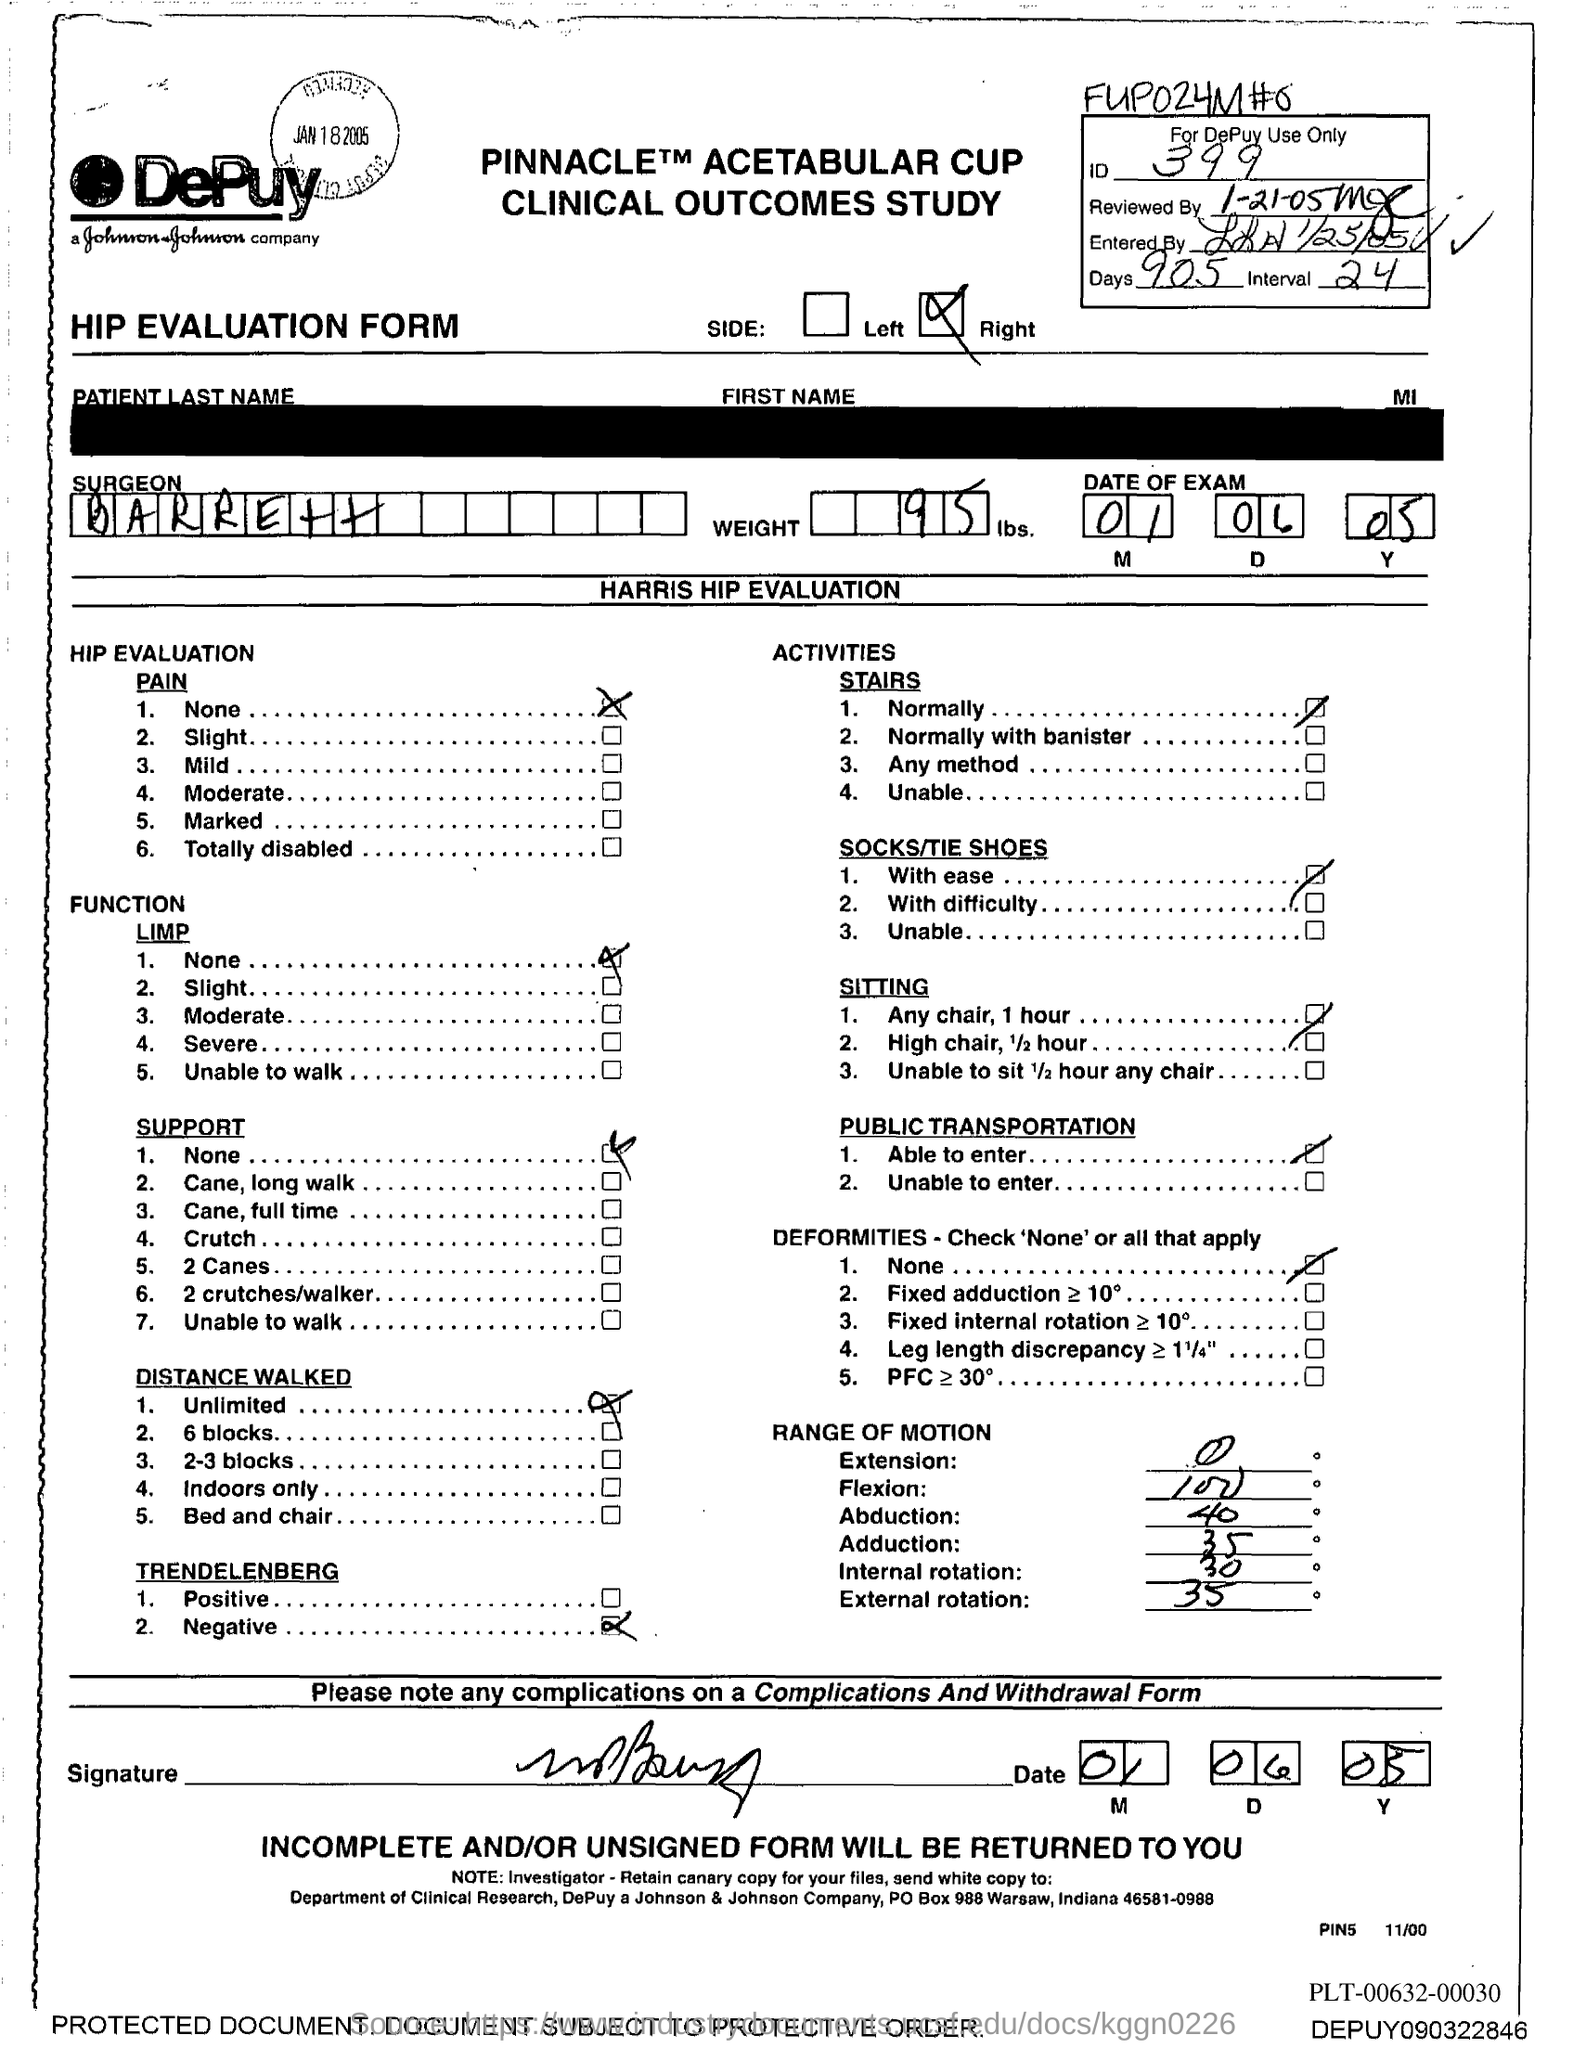Outline some significant characteristics in this image. The ID Number is 399. The weight is 95 pounds. The name of the surgeon is Barrett. 